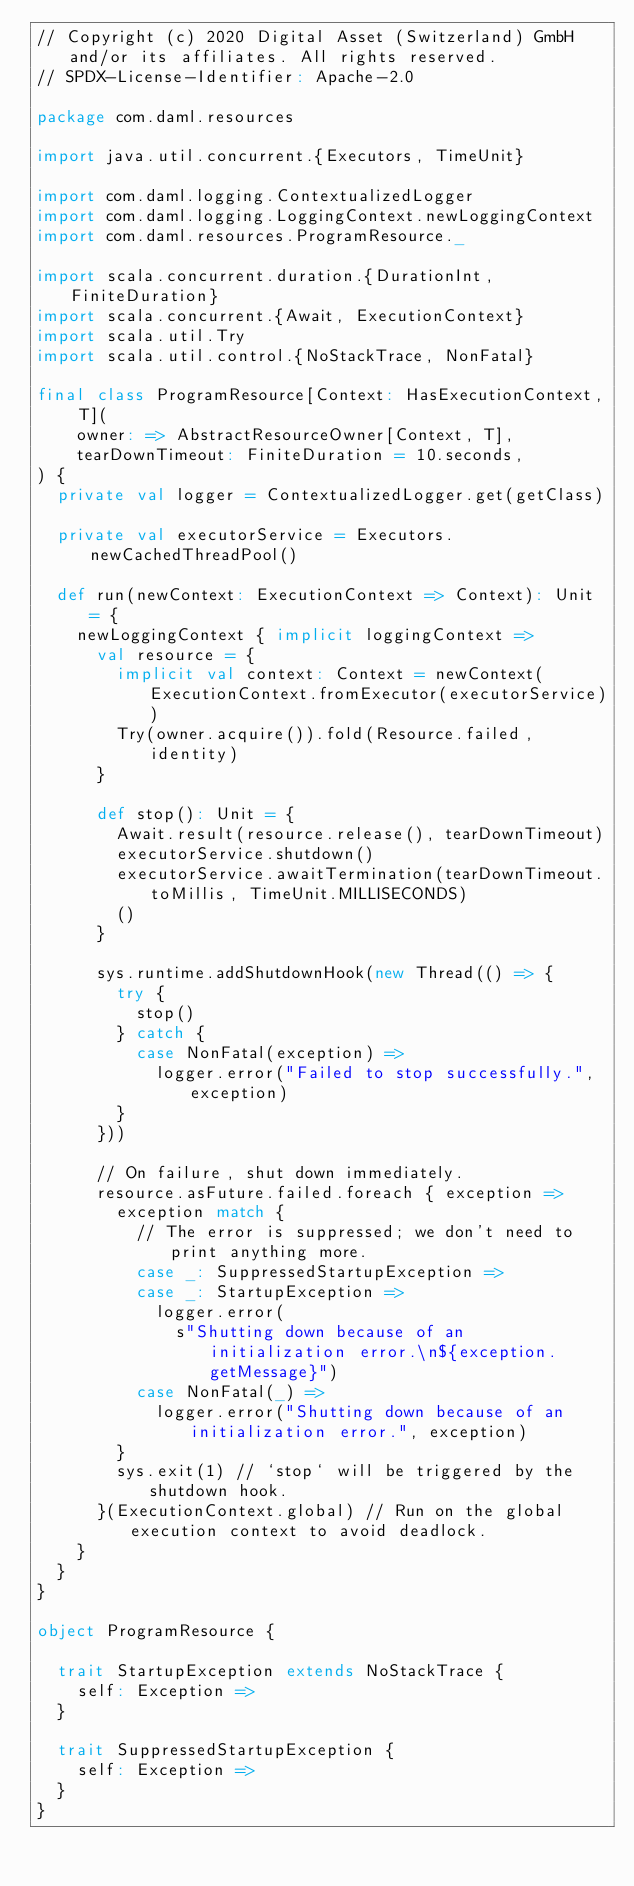Convert code to text. <code><loc_0><loc_0><loc_500><loc_500><_Scala_>// Copyright (c) 2020 Digital Asset (Switzerland) GmbH and/or its affiliates. All rights reserved.
// SPDX-License-Identifier: Apache-2.0

package com.daml.resources

import java.util.concurrent.{Executors, TimeUnit}

import com.daml.logging.ContextualizedLogger
import com.daml.logging.LoggingContext.newLoggingContext
import com.daml.resources.ProgramResource._

import scala.concurrent.duration.{DurationInt, FiniteDuration}
import scala.concurrent.{Await, ExecutionContext}
import scala.util.Try
import scala.util.control.{NoStackTrace, NonFatal}

final class ProgramResource[Context: HasExecutionContext, T](
    owner: => AbstractResourceOwner[Context, T],
    tearDownTimeout: FiniteDuration = 10.seconds,
) {
  private val logger = ContextualizedLogger.get(getClass)

  private val executorService = Executors.newCachedThreadPool()

  def run(newContext: ExecutionContext => Context): Unit = {
    newLoggingContext { implicit loggingContext =>
      val resource = {
        implicit val context: Context = newContext(ExecutionContext.fromExecutor(executorService))
        Try(owner.acquire()).fold(Resource.failed, identity)
      }

      def stop(): Unit = {
        Await.result(resource.release(), tearDownTimeout)
        executorService.shutdown()
        executorService.awaitTermination(tearDownTimeout.toMillis, TimeUnit.MILLISECONDS)
        ()
      }

      sys.runtime.addShutdownHook(new Thread(() => {
        try {
          stop()
        } catch {
          case NonFatal(exception) =>
            logger.error("Failed to stop successfully.", exception)
        }
      }))

      // On failure, shut down immediately.
      resource.asFuture.failed.foreach { exception =>
        exception match {
          // The error is suppressed; we don't need to print anything more.
          case _: SuppressedStartupException =>
          case _: StartupException =>
            logger.error(
              s"Shutting down because of an initialization error.\n${exception.getMessage}")
          case NonFatal(_) =>
            logger.error("Shutting down because of an initialization error.", exception)
        }
        sys.exit(1) // `stop` will be triggered by the shutdown hook.
      }(ExecutionContext.global) // Run on the global execution context to avoid deadlock.
    }
  }
}

object ProgramResource {

  trait StartupException extends NoStackTrace {
    self: Exception =>
  }

  trait SuppressedStartupException {
    self: Exception =>
  }
}
</code> 